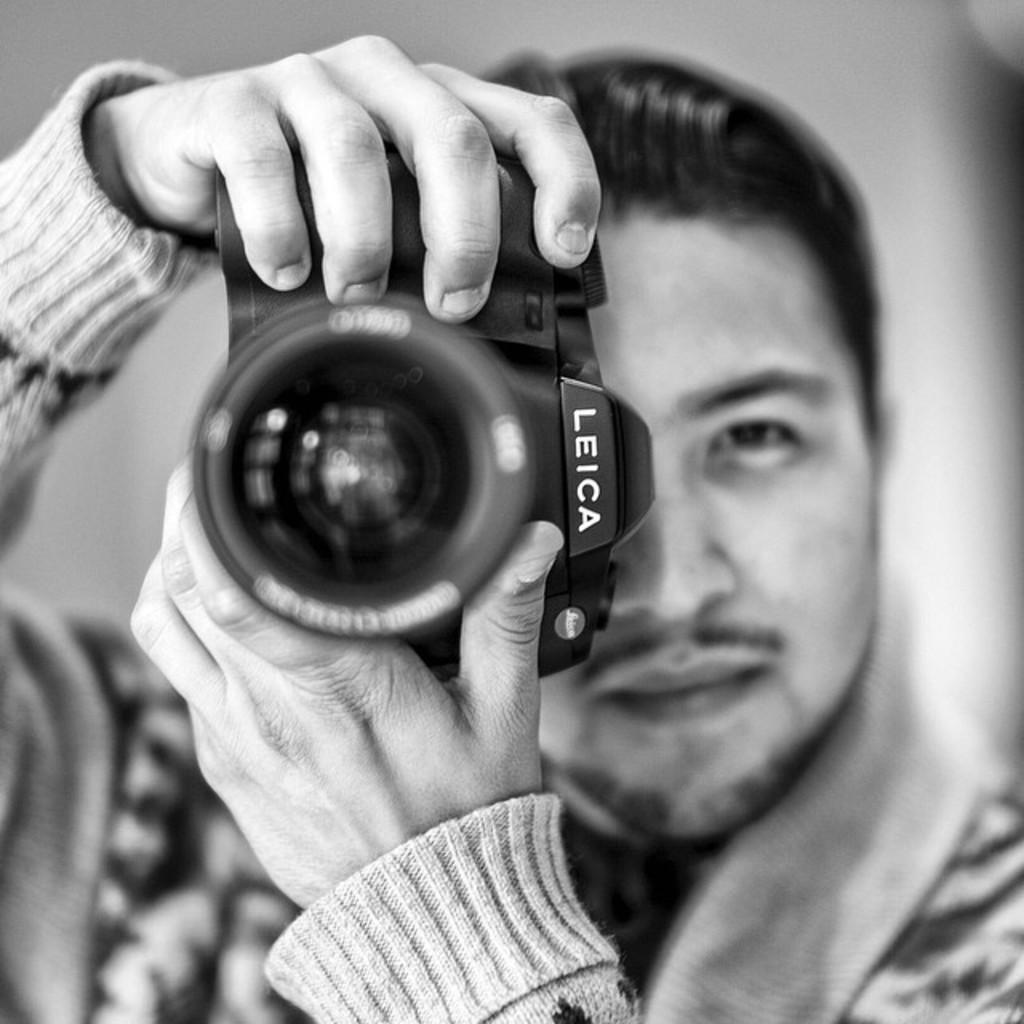What is the main subject of the image? There is a person in the image. What is the person holding in the image? The person is holding a camera. What type of pain is the person experiencing in the image? There is no indication of pain in the image; the person is simply holding a camera. What color is the toad sitting next to the person in the image? There is no toad present in the image. 